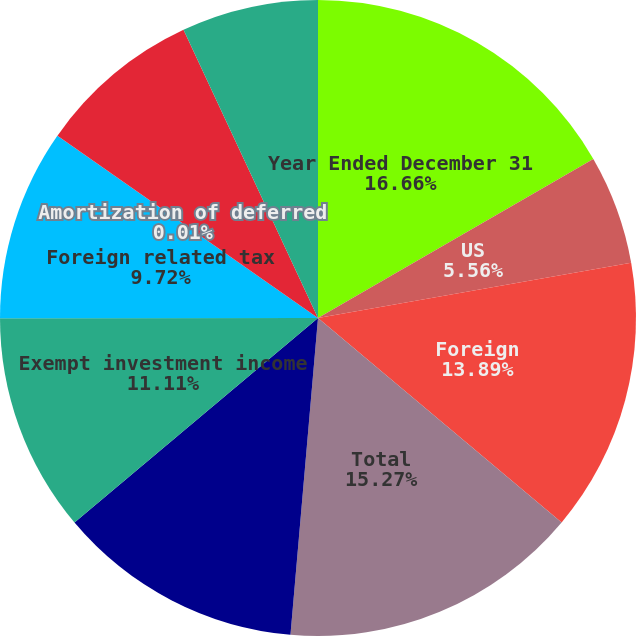Convert chart to OTSL. <chart><loc_0><loc_0><loc_500><loc_500><pie_chart><fcel>Year Ended December 31<fcel>US<fcel>Foreign<fcel>Total<fcel>Income tax expense at<fcel>Exempt investment income<fcel>Foreign related tax<fcel>Amortization of deferred<fcel>Taxes related to domestic<fcel>Partnership earnings not<nl><fcel>16.66%<fcel>5.56%<fcel>13.89%<fcel>15.27%<fcel>12.5%<fcel>11.11%<fcel>9.72%<fcel>0.01%<fcel>8.33%<fcel>6.95%<nl></chart> 